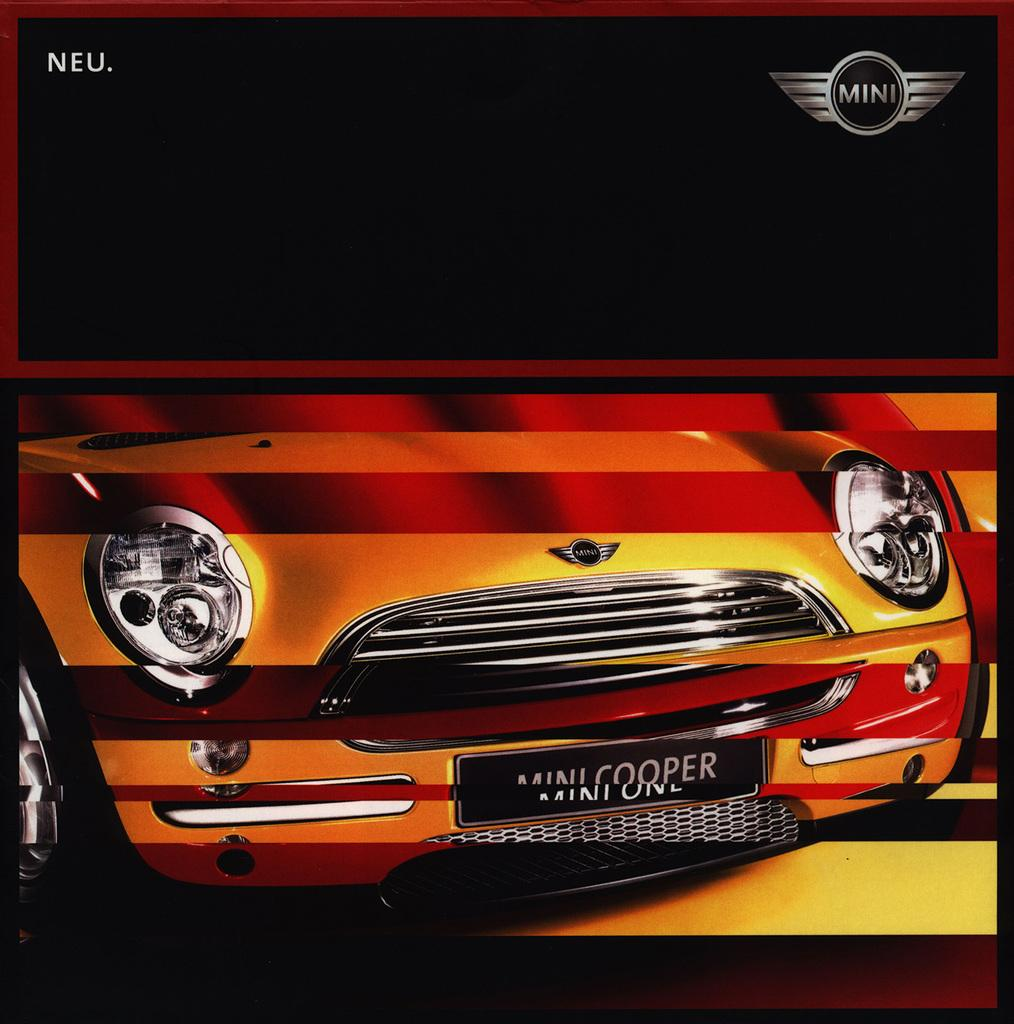What is the main subject of the image? The main subject of the image is the front part of a car. Can you describe any specific features of the car in the image? Unfortunately, the provided facts do not include any specific details about the car's features. Is there anything else visible in the image besides the car? The facts do not mention any other objects or elements in the image. How many rings are hanging from the rearview mirror in the image? There is no rearview mirror or rings present in the image, as it only contains the front part of a car. 